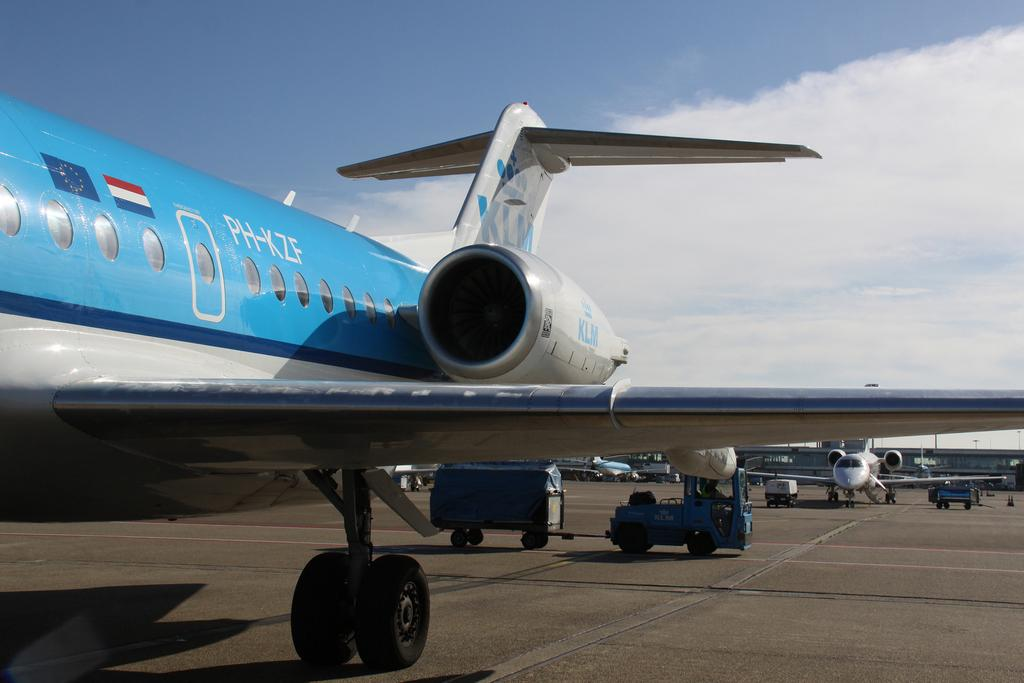<image>
Relay a brief, clear account of the picture shown. Plane PH-KZF is light blue and white in color. 